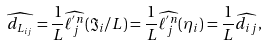Convert formula to latex. <formula><loc_0><loc_0><loc_500><loc_500>\widehat { d _ { L _ { i j } } } = \frac { 1 } { L } \widehat { \ell ^ { ^ { \prime } n } _ { j } } ( \Im _ { i } / L ) = \frac { 1 } { L } \widehat { \ell ^ { ^ { \prime } n } _ { j } } ( \eta _ { i } ) = \frac { 1 } { L } \widehat { d _ { i j } } ,</formula> 